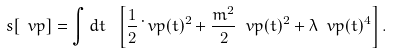<formula> <loc_0><loc_0><loc_500><loc_500>s [ \ v p ] = \int d t \ \left [ \frac { 1 } { 2 } \dot { \ } v p ( t ) ^ { 2 } + \frac { m ^ { 2 } } { 2 } \ v p ( t ) ^ { 2 } + \lambda \ v p ( t ) ^ { 4 } \right ] .</formula> 